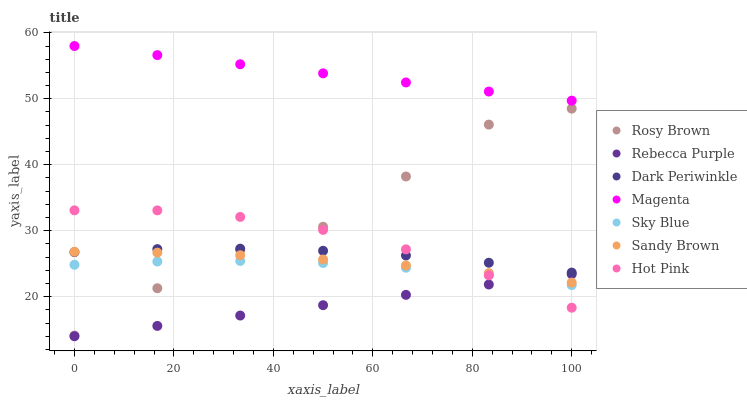Does Rebecca Purple have the minimum area under the curve?
Answer yes or no. Yes. Does Magenta have the maximum area under the curve?
Answer yes or no. Yes. Does Rosy Brown have the minimum area under the curve?
Answer yes or no. No. Does Rosy Brown have the maximum area under the curve?
Answer yes or no. No. Is Magenta the smoothest?
Answer yes or no. Yes. Is Rosy Brown the roughest?
Answer yes or no. Yes. Is Rebecca Purple the smoothest?
Answer yes or no. No. Is Rebecca Purple the roughest?
Answer yes or no. No. Does Rebecca Purple have the lowest value?
Answer yes or no. Yes. Does Rosy Brown have the lowest value?
Answer yes or no. No. Does Magenta have the highest value?
Answer yes or no. Yes. Does Rosy Brown have the highest value?
Answer yes or no. No. Is Sandy Brown less than Magenta?
Answer yes or no. Yes. Is Sandy Brown greater than Sky Blue?
Answer yes or no. Yes. Does Sky Blue intersect Rebecca Purple?
Answer yes or no. Yes. Is Sky Blue less than Rebecca Purple?
Answer yes or no. No. Is Sky Blue greater than Rebecca Purple?
Answer yes or no. No. Does Sandy Brown intersect Magenta?
Answer yes or no. No. 